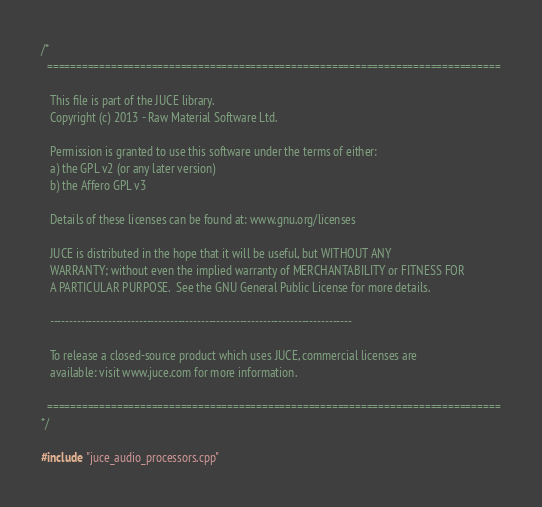<code> <loc_0><loc_0><loc_500><loc_500><_ObjectiveC_>/*
  ==============================================================================

   This file is part of the JUCE library.
   Copyright (c) 2013 - Raw Material Software Ltd.

   Permission is granted to use this software under the terms of either:
   a) the GPL v2 (or any later version)
   b) the Affero GPL v3

   Details of these licenses can be found at: www.gnu.org/licenses

   JUCE is distributed in the hope that it will be useful, but WITHOUT ANY
   WARRANTY; without even the implied warranty of MERCHANTABILITY or FITNESS FOR
   A PARTICULAR PURPOSE.  See the GNU General Public License for more details.

   ------------------------------------------------------------------------------

   To release a closed-source product which uses JUCE, commercial licenses are
   available: visit www.juce.com for more information.

  ==============================================================================
*/

#include "juce_audio_processors.cpp"
</code> 